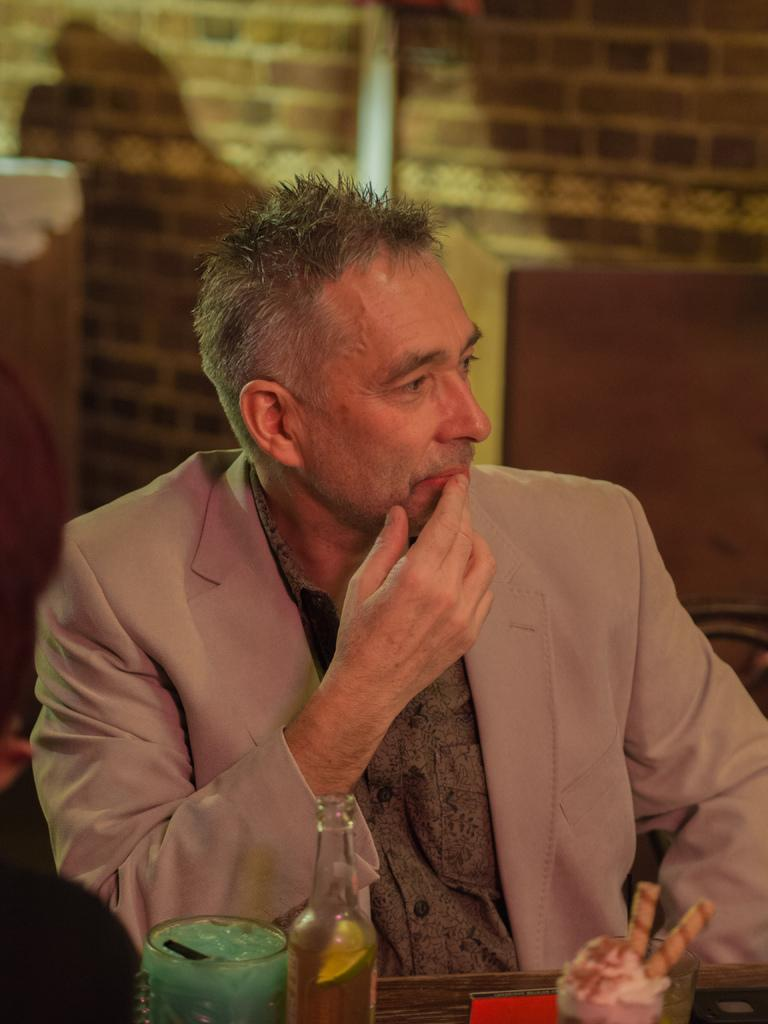What type of structure is visible in the image? There is a brick wall in the image. Who is present in the image? There is a man in the image. What is in front of the man? There is a table in front of the man. What can be seen on the table? There is a glass and a bottle on the table. How many fingers does the tramp have in the image? There is no tramp present in the image, so it is not possible to determine the number of fingers they might have. 